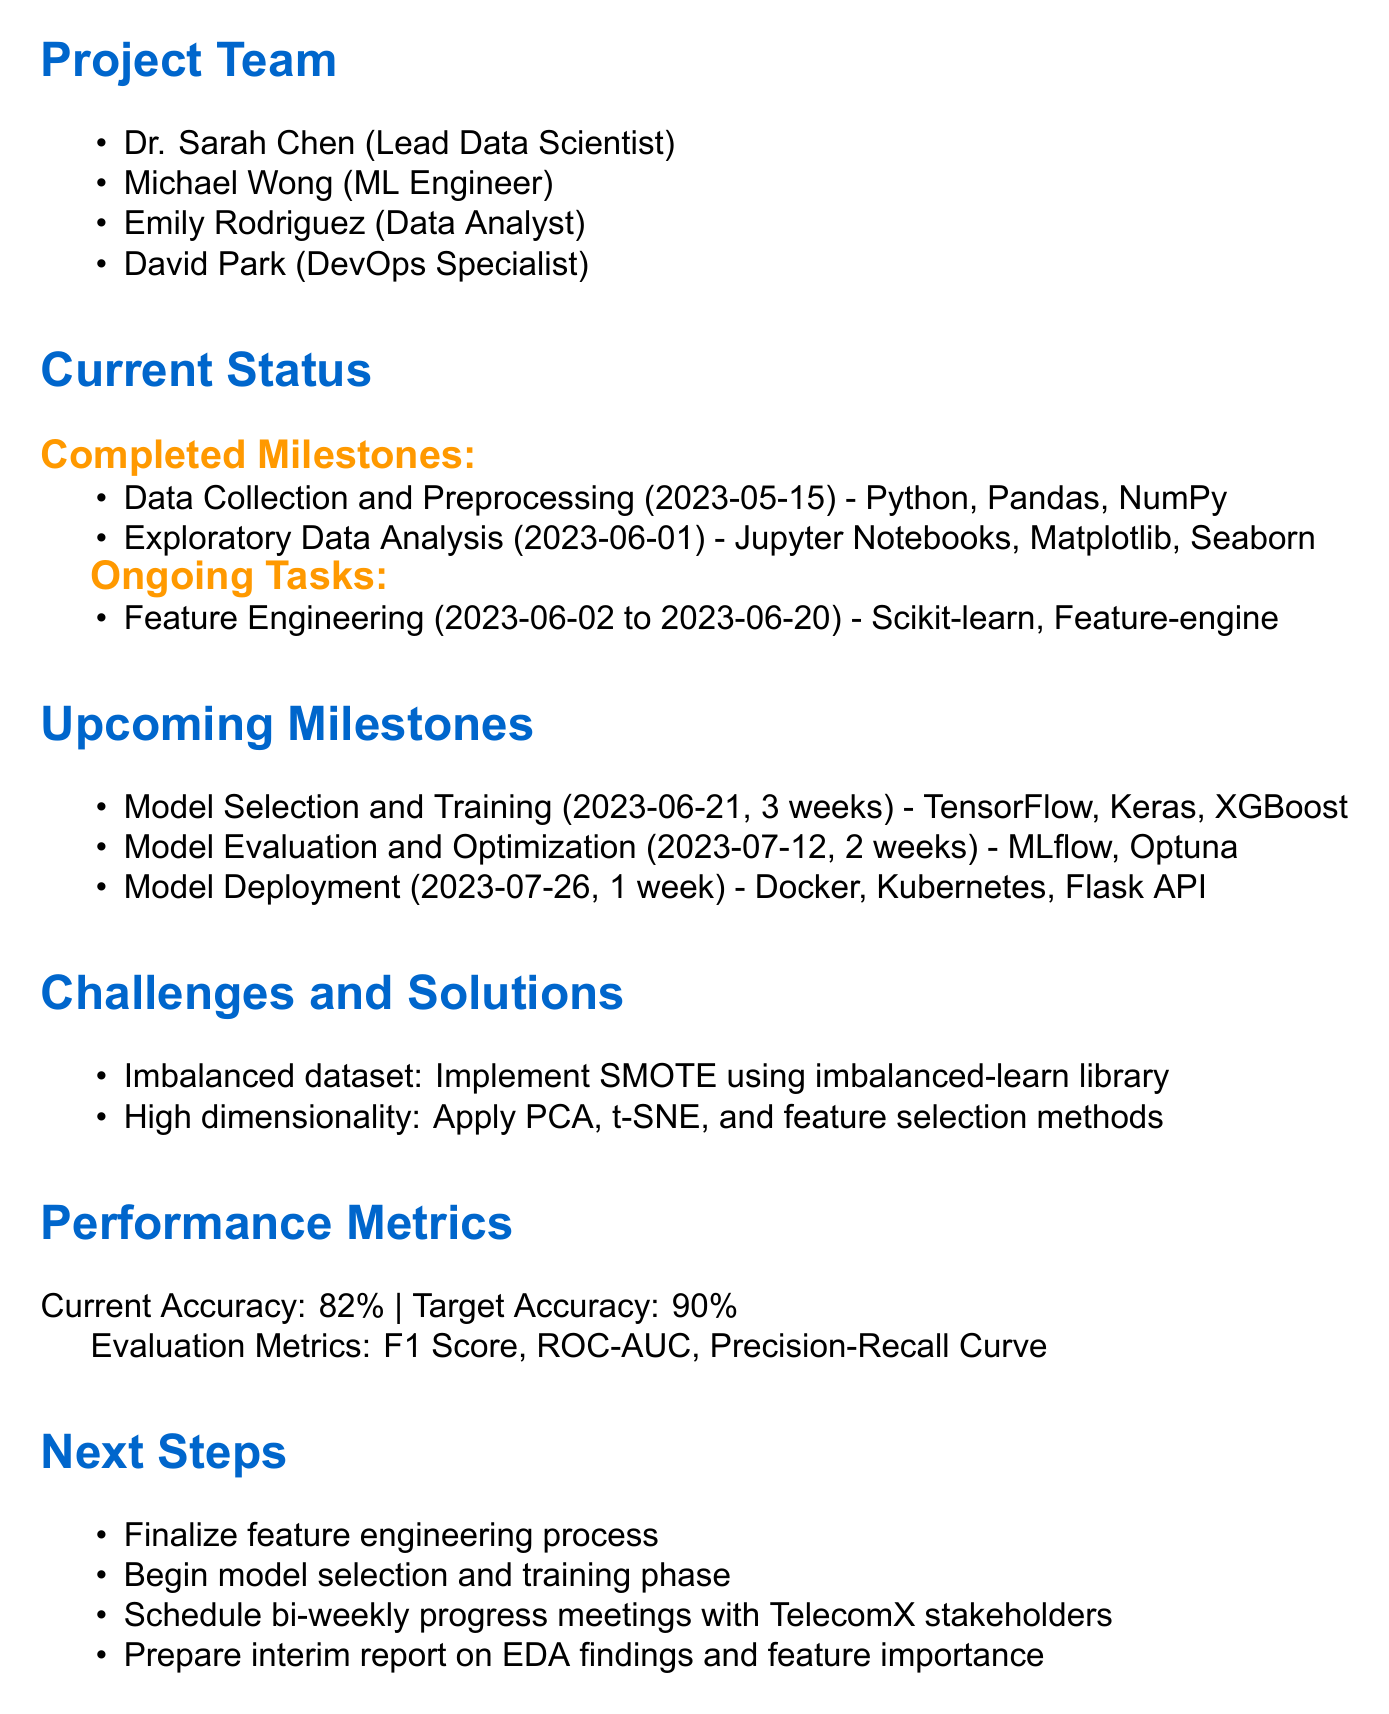what is the project name? The project name is stated in the introduction of the document.
Answer: Predictive Customer Churn Analysis who is the lead data scientist? The name of the lead data scientist is listed under the project team.
Answer: Dr. Sarah Chen when was data collection and preprocessing completed? This date can be found in the completed milestones section.
Answer: 2023-05-15 what tools are being used for feature engineering? The tools are specified in the ongoing tasks section.
Answer: Scikit-learn, Feature-engine what is the expected completion date for the project? The expected completion date is mentioned in the conclusion.
Answer: 2023-08-15 what is the target accuracy for the model? The target accuracy is detailed in the performance metrics section.
Answer: 90% what challenge is related to the dataset? This information can be found in the challenges section.
Answer: Imbalanced dataset how long will the model deployment take? The duration for model deployment is indicated in the upcoming milestones.
Answer: 1 week what is the next step after finalizing the feature engineering process? This is listed in the next steps section as the next action item.
Answer: Begin model selection and training phase 